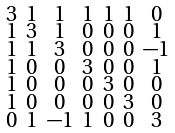<formula> <loc_0><loc_0><loc_500><loc_500>\begin{smallmatrix} 3 & 1 & 1 & 1 & 1 & 1 & 0 \\ 1 & 3 & 1 & 0 & 0 & 0 & 1 \\ 1 & 1 & 3 & 0 & 0 & 0 & - 1 \\ 1 & 0 & 0 & 3 & 0 & 0 & 1 \\ 1 & 0 & 0 & 0 & 3 & 0 & 0 \\ 1 & 0 & 0 & 0 & 0 & 3 & 0 \\ 0 & 1 & - 1 & 1 & 0 & 0 & 3 \end{smallmatrix}</formula> 